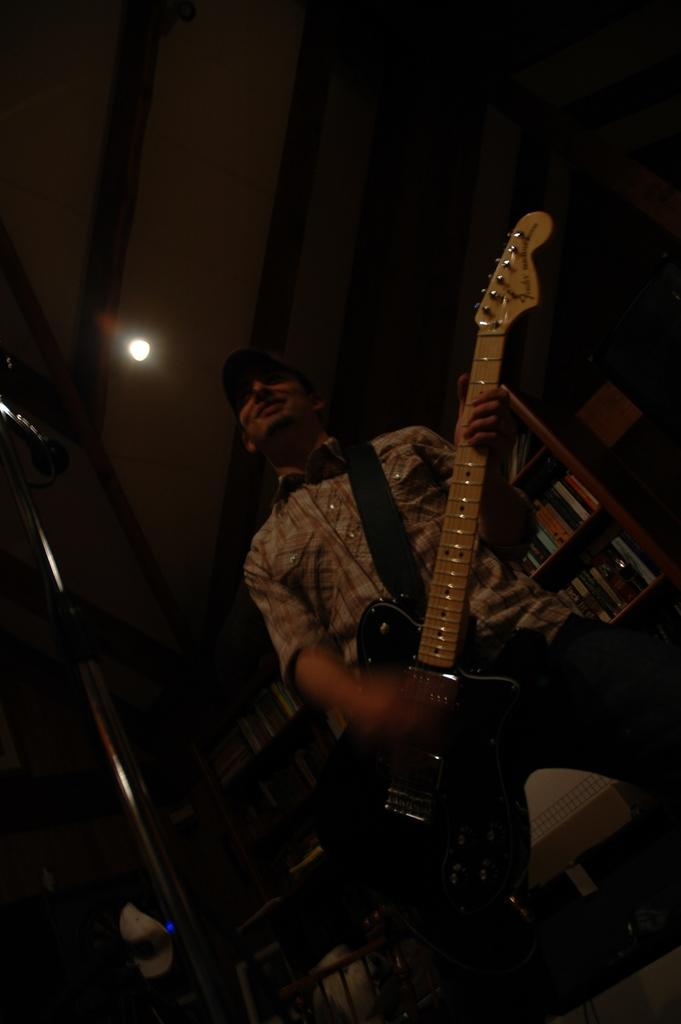Where was the image taken? The image was taken in a room. Can you describe the lighting in the room? The room is dark. What is the man in the image doing? The man is holding a guitar. What can be seen on the shelf in the background? There are books on the shelf. What is visible on the roof top in the background? There is a light on the roof top. What scent can be detected in the room in the image? There is no information about the scent in the room in the image. How many sisters are present in the image? There are no sisters mentioned or visible in the image. 